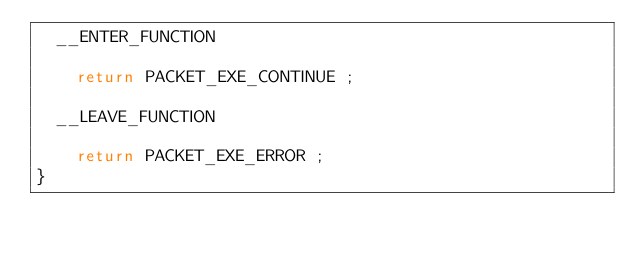Convert code to text. <code><loc_0><loc_0><loc_500><loc_500><_C++_>	__ENTER_FUNCTION

		return PACKET_EXE_CONTINUE ;

	__LEAVE_FUNCTION

		return PACKET_EXE_ERROR ;
}
</code> 